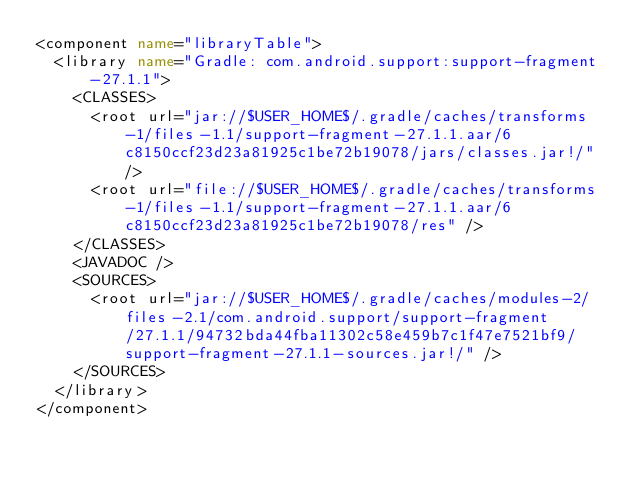Convert code to text. <code><loc_0><loc_0><loc_500><loc_500><_XML_><component name="libraryTable">
  <library name="Gradle: com.android.support:support-fragment-27.1.1">
    <CLASSES>
      <root url="jar://$USER_HOME$/.gradle/caches/transforms-1/files-1.1/support-fragment-27.1.1.aar/6c8150ccf23d23a81925c1be72b19078/jars/classes.jar!/" />
      <root url="file://$USER_HOME$/.gradle/caches/transforms-1/files-1.1/support-fragment-27.1.1.aar/6c8150ccf23d23a81925c1be72b19078/res" />
    </CLASSES>
    <JAVADOC />
    <SOURCES>
      <root url="jar://$USER_HOME$/.gradle/caches/modules-2/files-2.1/com.android.support/support-fragment/27.1.1/94732bda44fba11302c58e459b7c1f47e7521bf9/support-fragment-27.1.1-sources.jar!/" />
    </SOURCES>
  </library>
</component></code> 